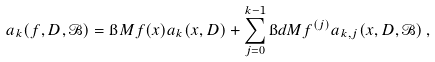<formula> <loc_0><loc_0><loc_500><loc_500>a _ { k } ( f , D , \mathcal { B } ) = \i M f ( x ) a _ { k } ( x , D ) + \sum _ { j = 0 } ^ { k - 1 } \i d M f ^ { ( j ) } a _ { k , j } ( x , D , \mathcal { B } ) \, ,</formula> 